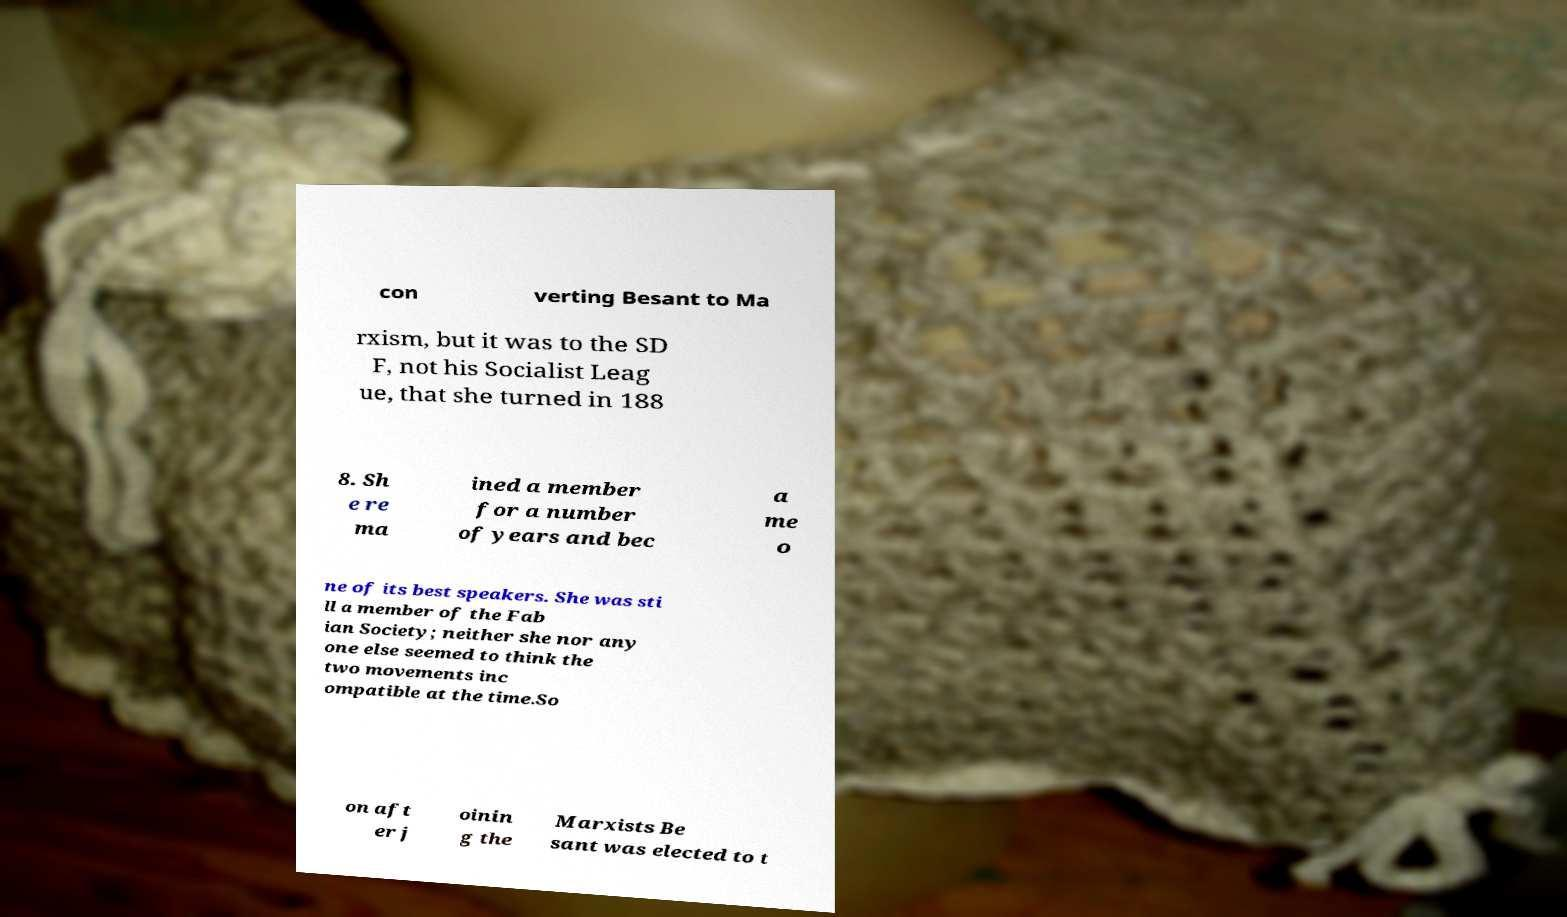I need the written content from this picture converted into text. Can you do that? con verting Besant to Ma rxism, but it was to the SD F, not his Socialist Leag ue, that she turned in 188 8. Sh e re ma ined a member for a number of years and bec a me o ne of its best speakers. She was sti ll a member of the Fab ian Society; neither she nor any one else seemed to think the two movements inc ompatible at the time.So on aft er j oinin g the Marxists Be sant was elected to t 